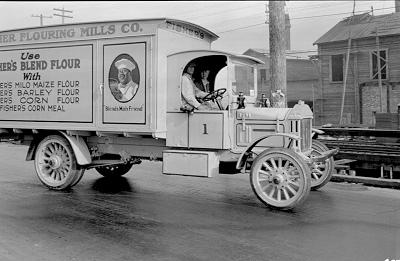Describe the building in the background of the image. A small, old wooden building with two windows is situated in the background, possibly part of the industrial or storage area of the company. Explain the key attributes of the image, including its style and color palette. The image is a black and white photograph, featuring an old-fashioned truck with various writings and images on it, two people inside, and is set against a backdrop with a wooden building and telephone poles. How many windows are visible on the building in the background, and where are they located? Two windows are shown on the side of the wooden building, near the middle of the structure. Provide a brief description of the scene depicted in the image. An old-fashioned flour truck with two people inside is being driven on a road, with a picture of a baker, a number 1, and the company name on its side, near a wooden building and telephone pole. What is the name of the company that owns the truck, and where is it written? The company's name is "Fisher Flouring Mills Co." and it is written on the front and side of the truck. Count and describe the tires of the vehicle in the image. There are 4 tires on the truck - 2 front tires which are thin, and 2 rear driver side tires which are old-style and thick. Detail the image of the baker seen on the truck. The image depicts a painted man wearing a large white baker's hat, on the side of the vehicle, apparently part of the company's branding and messaging. Identify the object near the front of the truck and describe it. A telephone pole is near the front of the truck, characterized by its thick tree trunk like base and power line connection. What can you infer about the people inside the truck? The people inside the truck are likely employees of Fisher Flouring Mills Co., driving the truck for flour delivery or other company-related tasks. What type of vehicle is in the image and what is its main function? The vehicle is an old-time delivery truck, mainly used for transporting flour for the Fisher Flouring Mills Co. You ought to detect the balloons tied to the telephone pole next to the truck. There is no mention of balloons in the image, so asking for balloons tied to the telephone pole is misleading. I need you to confirm the presence of a cat sitting on the edge of the road. There is no mention of a cat or any animals in the image, so asking for a cat on the road is misleading. Can you point out where the children playing with a ball near the truck are located? The image does not mention any children or ball near the truck, so this instruction is misleading. Please identify the position of the traffic light that's adjacent to the power line. There is no traffic light mentioned in the image or relating to the power line, so this instruction is misleading. Could you look for the blue bird perched on the top-end of the truck and tell me its position? This image is black and white, and there are no birds, so looking for a blue bird or any bird is misleading. Kindly confirm if you can spot the red farmer's market stand on the right corner of the road. The image is black and white, and there is no mention of a farmer's market stand. Asking for a colored stand is misleading. 